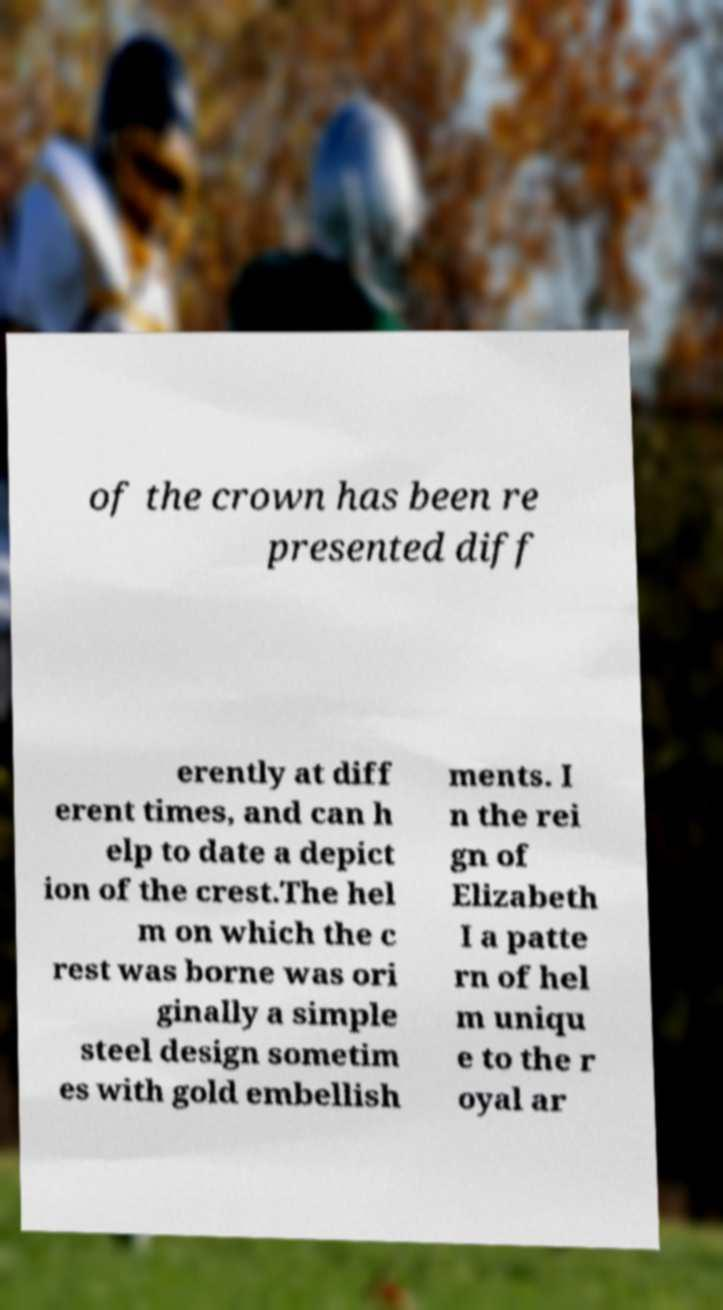For documentation purposes, I need the text within this image transcribed. Could you provide that? of the crown has been re presented diff erently at diff erent times, and can h elp to date a depict ion of the crest.The hel m on which the c rest was borne was ori ginally a simple steel design sometim es with gold embellish ments. I n the rei gn of Elizabeth I a patte rn of hel m uniqu e to the r oyal ar 